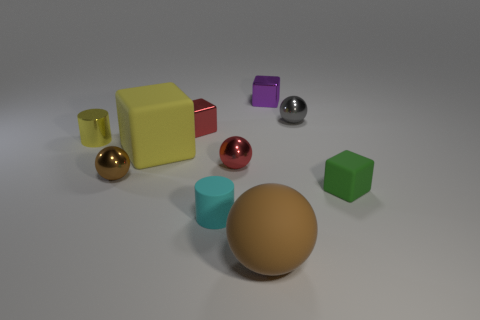What material is the tiny ball that is the same color as the large matte ball?
Offer a very short reply. Metal. Is the material of the tiny brown ball the same as the purple thing?
Ensure brevity in your answer.  Yes. There is a metal thing that is both to the left of the big rubber ball and behind the small yellow metal thing; what shape is it?
Offer a very short reply. Cube. What is the shape of the tiny purple thing that is the same material as the gray ball?
Provide a short and direct response. Cube. Is there a gray rubber thing?
Your answer should be compact. No. Are there any balls on the right side of the small cylinder that is on the right side of the shiny cylinder?
Offer a very short reply. Yes. There is a yellow thing that is the same shape as the tiny cyan thing; what material is it?
Your answer should be very brief. Metal. Is the number of large yellow objects greater than the number of large cyan shiny balls?
Ensure brevity in your answer.  Yes. Do the shiny cylinder and the big thing behind the big brown matte ball have the same color?
Offer a very short reply. Yes. There is a small sphere that is in front of the red cube and right of the yellow rubber thing; what is its color?
Offer a terse response. Red. 